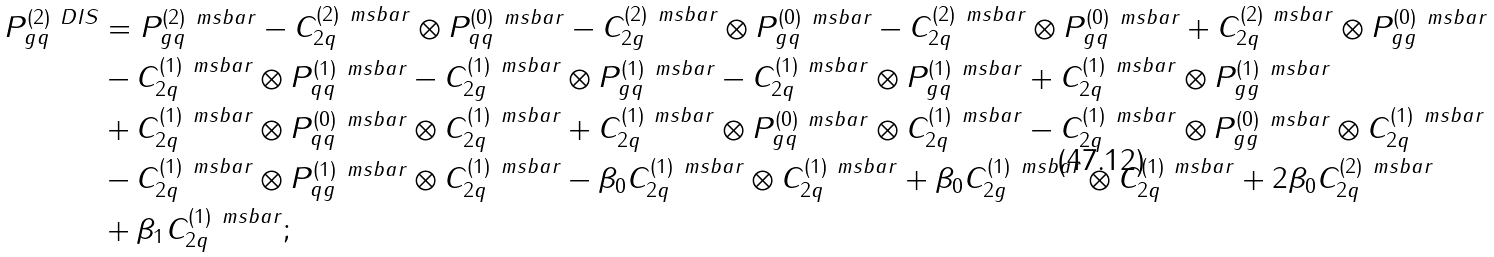Convert formula to latex. <formula><loc_0><loc_0><loc_500><loc_500>P _ { g q } ^ { ( 2 ) \ D I S } & = P _ { g q } ^ { ( 2 ) \ m s b a r } - C _ { 2 q } ^ { ( 2 ) \ m s b a r } \otimes P _ { q q } ^ { ( 0 ) \ m s b a r } - C _ { 2 g } ^ { ( 2 ) \ m s b a r } \otimes P _ { g q } ^ { ( 0 ) \ m s b a r } - C _ { 2 q } ^ { ( 2 ) \ m s b a r } \otimes P _ { g q } ^ { ( 0 ) \ m s b a r } + C _ { 2 q } ^ { ( 2 ) \ m s b a r } \otimes P _ { g g } ^ { ( 0 ) \ m s b a r } \\ & - C _ { 2 q } ^ { ( 1 ) \ m s b a r } \otimes P _ { q q } ^ { ( 1 ) \ m s b a r } - C _ { 2 g } ^ { ( 1 ) \ m s b a r } \otimes P _ { g q } ^ { ( 1 ) \ m s b a r } - C _ { 2 q } ^ { ( 1 ) \ m s b a r } \otimes P _ { g q } ^ { ( 1 ) \ m s b a r } + C _ { 2 q } ^ { ( 1 ) \ m s b a r } \otimes P _ { g g } ^ { ( 1 ) \ m s b a r } \\ & + C _ { 2 q } ^ { ( 1 ) \ m s b a r } \otimes P _ { q q } ^ { ( 0 ) \ m s b a r } \otimes C _ { 2 q } ^ { ( 1 ) \ m s b a r } + C _ { 2 q } ^ { ( 1 ) \ m s b a r } \otimes P _ { g q } ^ { ( 0 ) \ m s b a r } \otimes C _ { 2 q } ^ { ( 1 ) \ m s b a r } - C _ { 2 q } ^ { ( 1 ) \ m s b a r } \otimes P _ { g g } ^ { ( 0 ) \ m s b a r } \otimes C _ { 2 q } ^ { ( 1 ) \ m s b a r } \\ & - C _ { 2 q } ^ { ( 1 ) \ m s b a r } \otimes P _ { q g } ^ { ( 1 ) \ m s b a r } \otimes C _ { 2 q } ^ { ( 1 ) \ m s b a r } - \beta _ { 0 } C _ { 2 q } ^ { ( 1 ) \ m s b a r } \otimes C _ { 2 q } ^ { ( 1 ) \ m s b a r } + \beta _ { 0 } C _ { 2 g } ^ { ( 1 ) \ m s b a r } \otimes C _ { 2 q } ^ { ( 1 ) \ m s b a r } + 2 \beta _ { 0 } C _ { 2 q } ^ { ( 2 ) \ m s b a r } \\ & + \beta _ { 1 } C _ { 2 q } ^ { ( 1 ) \ m s b a r } ;</formula> 